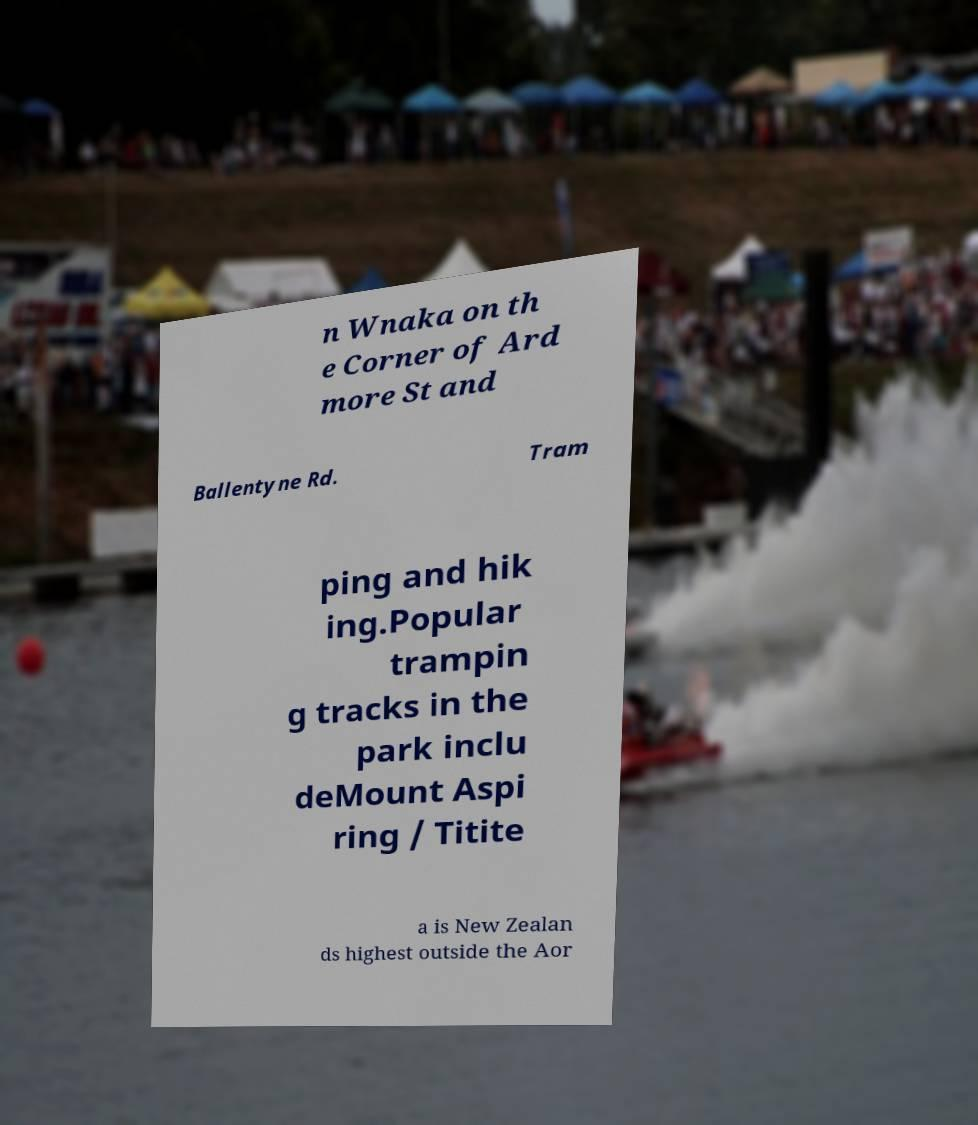Can you accurately transcribe the text from the provided image for me? n Wnaka on th e Corner of Ard more St and Ballentyne Rd. Tram ping and hik ing.Popular trampin g tracks in the park inclu deMount Aspi ring / Titite a is New Zealan ds highest outside the Aor 